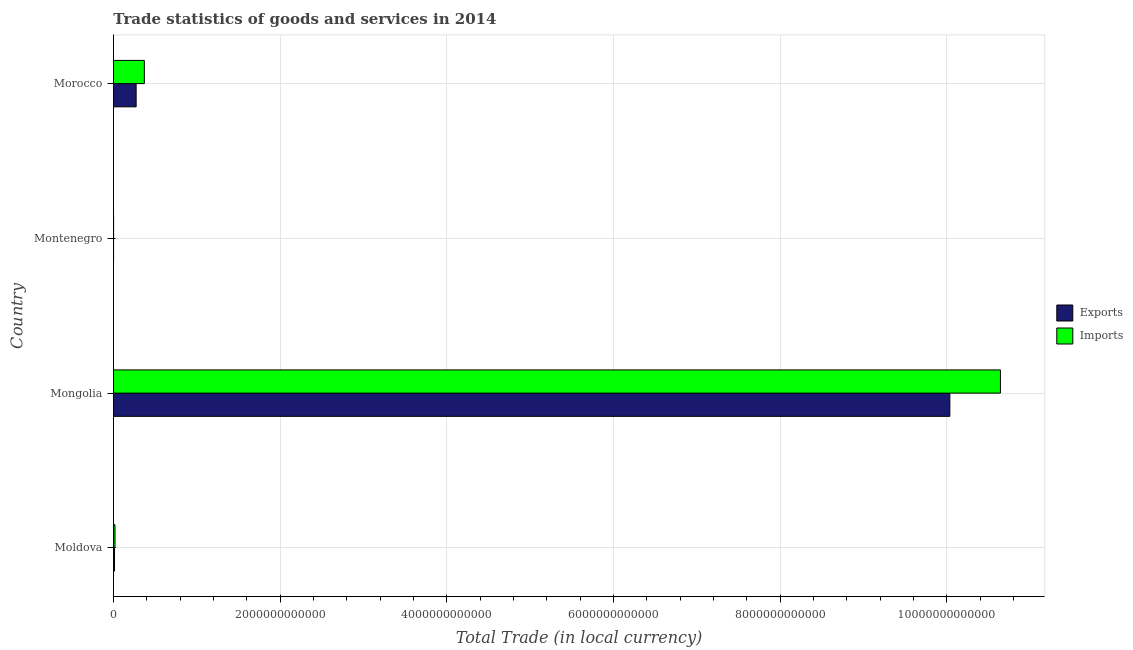How many groups of bars are there?
Offer a terse response. 4. How many bars are there on the 2nd tick from the top?
Your answer should be very brief. 2. What is the label of the 3rd group of bars from the top?
Give a very brief answer. Mongolia. What is the imports of goods and services in Montenegro?
Make the answer very short. 1.46e+09. Across all countries, what is the maximum export of goods and services?
Your response must be concise. 1.00e+13. Across all countries, what is the minimum export of goods and services?
Keep it short and to the point. 8.84e+08. In which country was the export of goods and services maximum?
Provide a succinct answer. Mongolia. In which country was the export of goods and services minimum?
Make the answer very short. Montenegro. What is the total export of goods and services in the graph?
Your answer should be compact. 1.03e+13. What is the difference between the export of goods and services in Montenegro and that in Morocco?
Your answer should be compact. -2.71e+11. What is the difference between the export of goods and services in Mongolia and the imports of goods and services in Montenegro?
Ensure brevity in your answer.  1.00e+13. What is the average imports of goods and services per country?
Provide a short and direct response. 2.76e+12. What is the difference between the export of goods and services and imports of goods and services in Montenegro?
Your answer should be very brief. -5.76e+08. In how many countries, is the imports of goods and services greater than 6000000000000 LCU?
Ensure brevity in your answer.  1. What is the ratio of the imports of goods and services in Moldova to that in Morocco?
Offer a terse response. 0.05. Is the export of goods and services in Moldova less than that in Morocco?
Your response must be concise. Yes. What is the difference between the highest and the second highest imports of goods and services?
Offer a terse response. 1.03e+13. What is the difference between the highest and the lowest export of goods and services?
Your answer should be compact. 1.00e+13. What does the 2nd bar from the top in Morocco represents?
Provide a succinct answer. Exports. What does the 2nd bar from the bottom in Mongolia represents?
Offer a very short reply. Imports. How many bars are there?
Keep it short and to the point. 8. What is the difference between two consecutive major ticks on the X-axis?
Offer a terse response. 2.00e+12. Does the graph contain grids?
Your answer should be very brief. Yes. How many legend labels are there?
Provide a short and direct response. 2. What is the title of the graph?
Ensure brevity in your answer.  Trade statistics of goods and services in 2014. Does "Constant 2005 US$" appear as one of the legend labels in the graph?
Provide a succinct answer. No. What is the label or title of the X-axis?
Keep it short and to the point. Total Trade (in local currency). What is the label or title of the Y-axis?
Offer a terse response. Country. What is the Total Trade (in local currency) of Exports in Moldova?
Offer a very short reply. 1.27e+1. What is the Total Trade (in local currency) in Imports in Moldova?
Give a very brief answer. 1.82e+1. What is the Total Trade (in local currency) in Exports in Mongolia?
Keep it short and to the point. 1.00e+13. What is the Total Trade (in local currency) in Imports in Mongolia?
Give a very brief answer. 1.06e+13. What is the Total Trade (in local currency) of Exports in Montenegro?
Give a very brief answer. 8.84e+08. What is the Total Trade (in local currency) of Imports in Montenegro?
Your answer should be compact. 1.46e+09. What is the Total Trade (in local currency) in Exports in Morocco?
Keep it short and to the point. 2.72e+11. What is the Total Trade (in local currency) of Imports in Morocco?
Offer a very short reply. 3.70e+11. Across all countries, what is the maximum Total Trade (in local currency) in Exports?
Offer a terse response. 1.00e+13. Across all countries, what is the maximum Total Trade (in local currency) in Imports?
Provide a succinct answer. 1.06e+13. Across all countries, what is the minimum Total Trade (in local currency) of Exports?
Offer a terse response. 8.84e+08. Across all countries, what is the minimum Total Trade (in local currency) of Imports?
Offer a terse response. 1.46e+09. What is the total Total Trade (in local currency) in Exports in the graph?
Provide a succinct answer. 1.03e+13. What is the total Total Trade (in local currency) in Imports in the graph?
Provide a short and direct response. 1.10e+13. What is the difference between the Total Trade (in local currency) in Exports in Moldova and that in Mongolia?
Make the answer very short. -1.00e+13. What is the difference between the Total Trade (in local currency) of Imports in Moldova and that in Mongolia?
Keep it short and to the point. -1.06e+13. What is the difference between the Total Trade (in local currency) of Exports in Moldova and that in Montenegro?
Provide a succinct answer. 1.18e+1. What is the difference between the Total Trade (in local currency) of Imports in Moldova and that in Montenegro?
Your answer should be compact. 1.67e+1. What is the difference between the Total Trade (in local currency) in Exports in Moldova and that in Morocco?
Provide a short and direct response. -2.59e+11. What is the difference between the Total Trade (in local currency) in Imports in Moldova and that in Morocco?
Ensure brevity in your answer.  -3.52e+11. What is the difference between the Total Trade (in local currency) in Exports in Mongolia and that in Montenegro?
Your answer should be very brief. 1.00e+13. What is the difference between the Total Trade (in local currency) of Imports in Mongolia and that in Montenegro?
Give a very brief answer. 1.06e+13. What is the difference between the Total Trade (in local currency) of Exports in Mongolia and that in Morocco?
Ensure brevity in your answer.  9.77e+12. What is the difference between the Total Trade (in local currency) in Imports in Mongolia and that in Morocco?
Keep it short and to the point. 1.03e+13. What is the difference between the Total Trade (in local currency) of Exports in Montenegro and that in Morocco?
Provide a short and direct response. -2.71e+11. What is the difference between the Total Trade (in local currency) of Imports in Montenegro and that in Morocco?
Keep it short and to the point. -3.69e+11. What is the difference between the Total Trade (in local currency) of Exports in Moldova and the Total Trade (in local currency) of Imports in Mongolia?
Provide a succinct answer. -1.06e+13. What is the difference between the Total Trade (in local currency) of Exports in Moldova and the Total Trade (in local currency) of Imports in Montenegro?
Your answer should be very brief. 1.12e+1. What is the difference between the Total Trade (in local currency) in Exports in Moldova and the Total Trade (in local currency) in Imports in Morocco?
Make the answer very short. -3.58e+11. What is the difference between the Total Trade (in local currency) in Exports in Mongolia and the Total Trade (in local currency) in Imports in Montenegro?
Offer a very short reply. 1.00e+13. What is the difference between the Total Trade (in local currency) in Exports in Mongolia and the Total Trade (in local currency) in Imports in Morocco?
Keep it short and to the point. 9.67e+12. What is the difference between the Total Trade (in local currency) of Exports in Montenegro and the Total Trade (in local currency) of Imports in Morocco?
Offer a terse response. -3.70e+11. What is the average Total Trade (in local currency) in Exports per country?
Ensure brevity in your answer.  2.58e+12. What is the average Total Trade (in local currency) of Imports per country?
Keep it short and to the point. 2.76e+12. What is the difference between the Total Trade (in local currency) in Exports and Total Trade (in local currency) in Imports in Moldova?
Ensure brevity in your answer.  -5.55e+09. What is the difference between the Total Trade (in local currency) of Exports and Total Trade (in local currency) of Imports in Mongolia?
Offer a terse response. -6.07e+11. What is the difference between the Total Trade (in local currency) in Exports and Total Trade (in local currency) in Imports in Montenegro?
Keep it short and to the point. -5.76e+08. What is the difference between the Total Trade (in local currency) of Exports and Total Trade (in local currency) of Imports in Morocco?
Offer a terse response. -9.86e+1. What is the ratio of the Total Trade (in local currency) in Exports in Moldova to that in Mongolia?
Make the answer very short. 0. What is the ratio of the Total Trade (in local currency) in Imports in Moldova to that in Mongolia?
Offer a terse response. 0. What is the ratio of the Total Trade (in local currency) of Exports in Moldova to that in Montenegro?
Give a very brief answer. 14.31. What is the ratio of the Total Trade (in local currency) of Imports in Moldova to that in Montenegro?
Your answer should be very brief. 12.47. What is the ratio of the Total Trade (in local currency) of Exports in Moldova to that in Morocco?
Your answer should be very brief. 0.05. What is the ratio of the Total Trade (in local currency) of Imports in Moldova to that in Morocco?
Provide a succinct answer. 0.05. What is the ratio of the Total Trade (in local currency) of Exports in Mongolia to that in Montenegro?
Give a very brief answer. 1.14e+04. What is the ratio of the Total Trade (in local currency) in Imports in Mongolia to that in Montenegro?
Keep it short and to the point. 7291.46. What is the ratio of the Total Trade (in local currency) in Exports in Mongolia to that in Morocco?
Offer a very short reply. 36.92. What is the ratio of the Total Trade (in local currency) of Imports in Mongolia to that in Morocco?
Provide a succinct answer. 28.73. What is the ratio of the Total Trade (in local currency) in Exports in Montenegro to that in Morocco?
Offer a terse response. 0. What is the ratio of the Total Trade (in local currency) of Imports in Montenegro to that in Morocco?
Your answer should be compact. 0. What is the difference between the highest and the second highest Total Trade (in local currency) of Exports?
Keep it short and to the point. 9.77e+12. What is the difference between the highest and the second highest Total Trade (in local currency) in Imports?
Your answer should be very brief. 1.03e+13. What is the difference between the highest and the lowest Total Trade (in local currency) of Exports?
Provide a succinct answer. 1.00e+13. What is the difference between the highest and the lowest Total Trade (in local currency) in Imports?
Your response must be concise. 1.06e+13. 